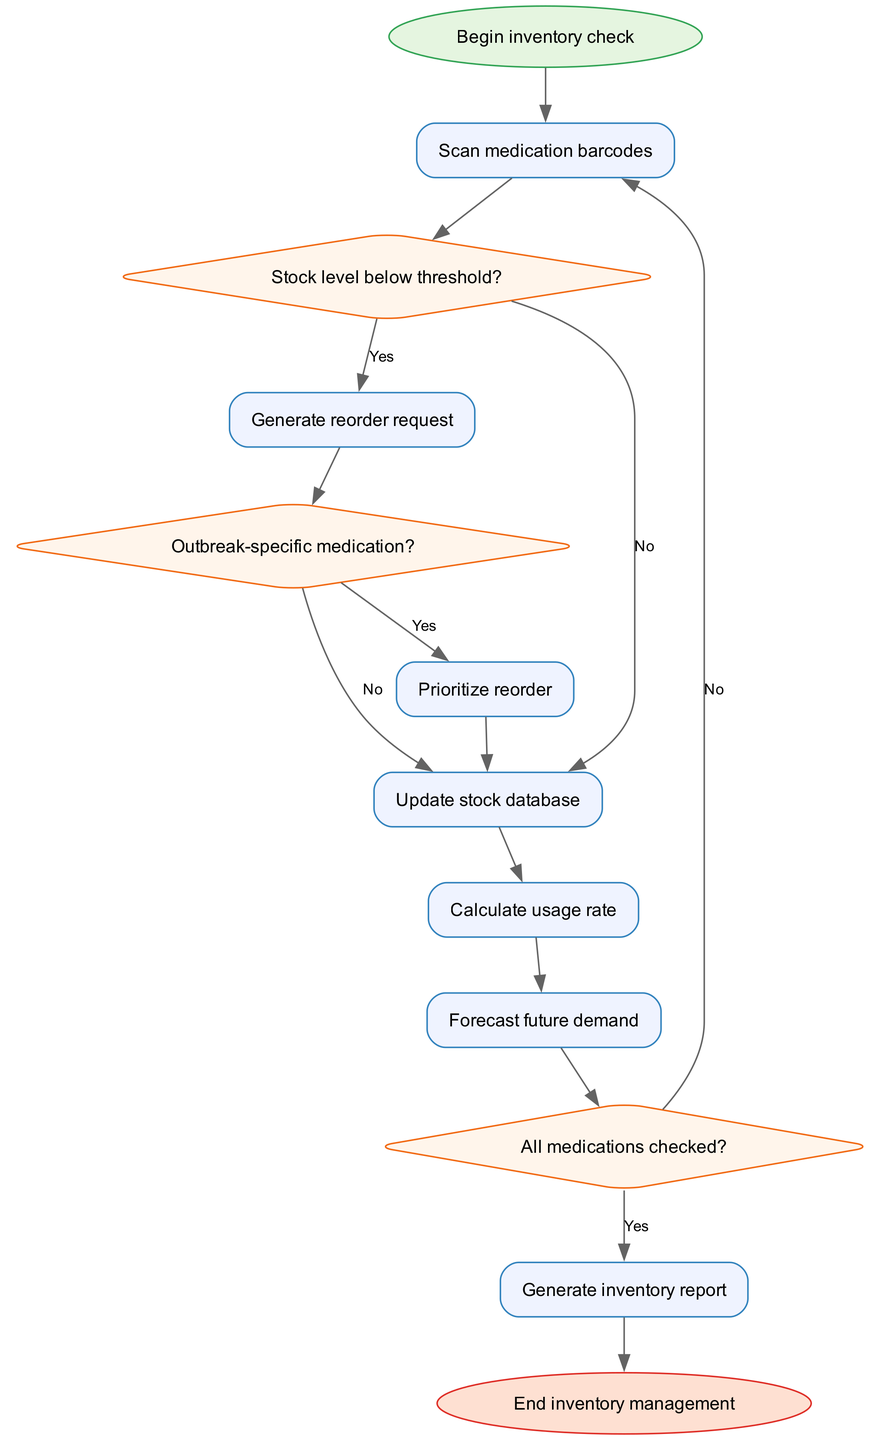What is the starting point of the inventory management process? The starting point is marked by the "Begin inventory check" node. This is the first element in the flowchart, indicating where the process begins.
Answer: Begin inventory check How many decision nodes are in the flowchart? There are three decision nodes: "Stock level below threshold?", "Outbreak-specific medication?", and "All medications checked?". These nodes require a yes or no answer to determine the flow of the process.
Answer: 3 What action is taken if the stock level is below threshold? If the stock level is below threshold, the flowchart indicates that a "Generate reorder request" process is initiated. This follows directly from the decision node labeled "Stock level below threshold?" with a "Yes" label.
Answer: Generate reorder request What does the process "Calculate usage rate" lead to? The process "Calculate usage rate" leads to "Forecast future demand". This is the next logical step in the flow after calculating how much medication is being used over time.
Answer: Forecast future demand What happens if the medications are not all checked? If not all medications are checked, the flowchart directs back to the "Scan medication barcodes" process. This indicates that further scanning of the medications is necessary to complete the inventory check.
Answer: Scan medication barcodes What is produced at the end of the inventory management flow? At the end of the flow, "Generate inventory report" is produced, indicating that a summary of the inventory status is created after all checks are complete.
Answer: Generate inventory report If the medication is outbreak-specific, what is prioritized? If the medication is identified as outbreak-specific, the process "Prioritize reorder" is executed to emphasize the importance of restocking these critical medications.
Answer: Prioritize reorder 